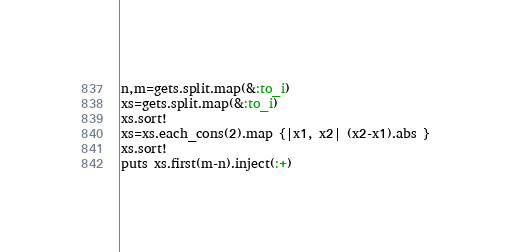Convert code to text. <code><loc_0><loc_0><loc_500><loc_500><_Ruby_>n,m=gets.split.map(&:to_i)
xs=gets.split.map(&:to_i)
xs.sort!
xs=xs.each_cons(2).map {|x1, x2| (x2-x1).abs }
xs.sort!
puts xs.first(m-n).inject(:+)</code> 